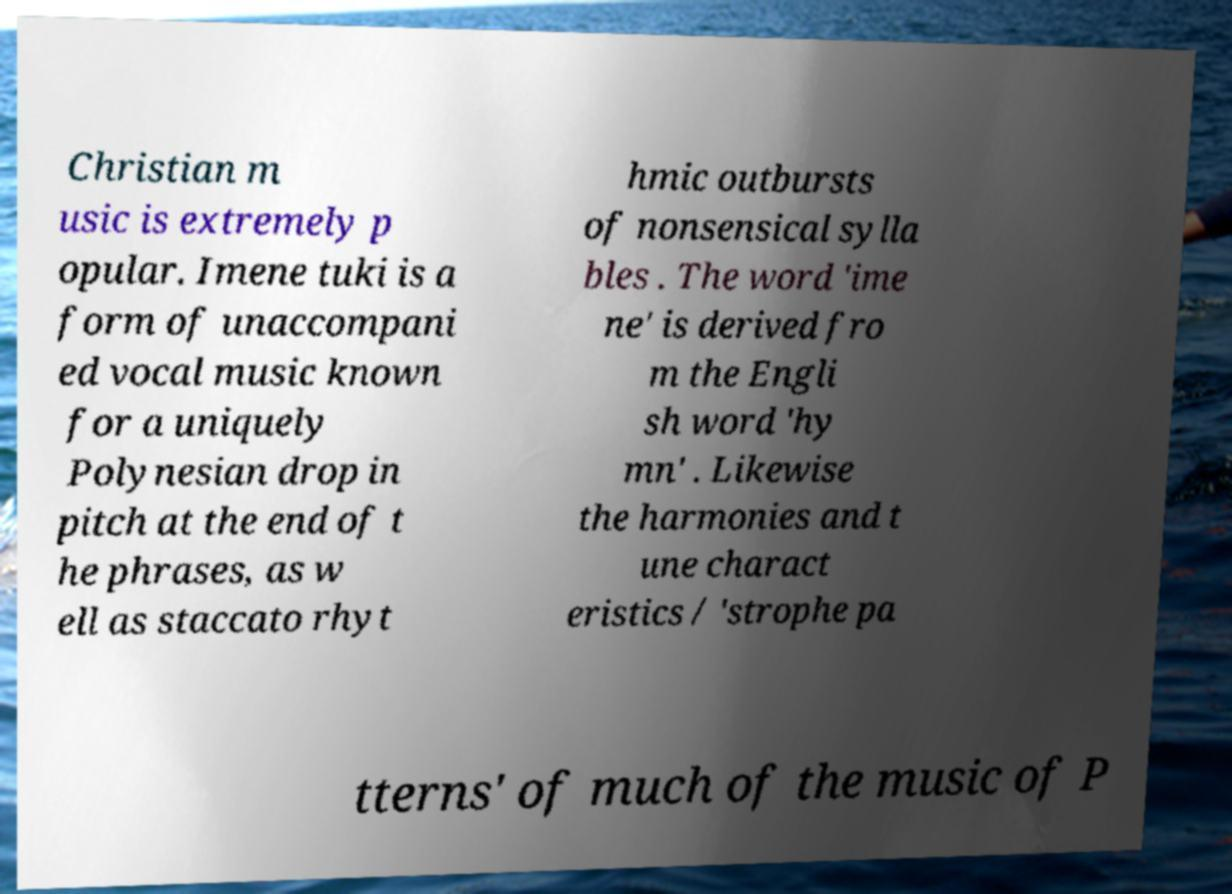Can you accurately transcribe the text from the provided image for me? Christian m usic is extremely p opular. Imene tuki is a form of unaccompani ed vocal music known for a uniquely Polynesian drop in pitch at the end of t he phrases, as w ell as staccato rhyt hmic outbursts of nonsensical sylla bles . The word 'ime ne' is derived fro m the Engli sh word 'hy mn' . Likewise the harmonies and t une charact eristics / 'strophe pa tterns' of much of the music of P 